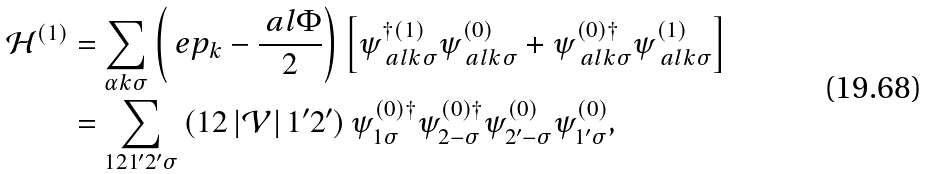Convert formula to latex. <formula><loc_0><loc_0><loc_500><loc_500>\mathcal { H } ^ { ( 1 ) } & = \sum _ { \alpha k \sigma } \left ( \ e p _ { k } - \frac { \ a l \Phi } { 2 } \right ) \left [ \psi ^ { \dag ( 1 ) } _ { \ a l k \sigma } \psi ^ { ( 0 ) } _ { \ a l k \sigma } + \psi ^ { ( 0 ) \dag } _ { \ a l k \sigma } \psi ^ { ( 1 ) } _ { \ a l k \sigma } \right ] \\ & = \sum _ { 1 2 1 ^ { \prime } 2 ^ { \prime } \sigma } \left ( 1 2 \left | \mathcal { V } \right | 1 ^ { \prime } 2 ^ { \prime } \right ) \psi ^ { ( 0 ) \dag } _ { 1 \sigma } \psi ^ { ( 0 ) \dag } _ { 2 - \sigma } \psi ^ { ( 0 ) } _ { 2 ^ { \prime } - \sigma } \psi ^ { ( 0 ) } _ { 1 ^ { \prime } \sigma } ,</formula> 